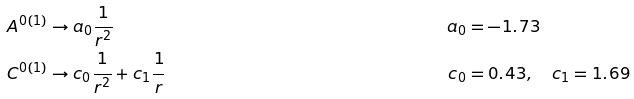<formula> <loc_0><loc_0><loc_500><loc_500>A ^ { 0 ( 1 ) } & \rightarrow a _ { 0 } \frac { 1 } { r ^ { 2 } } & a _ { 0 } & = - 1 . 7 3 \\ C ^ { 0 ( 1 ) } & \rightarrow c _ { 0 } \frac { 1 } { r ^ { 2 } } + c _ { 1 } \frac { 1 } { r } & c _ { 0 } & = 0 . 4 3 , \quad c _ { 1 } = 1 . 6 9</formula> 